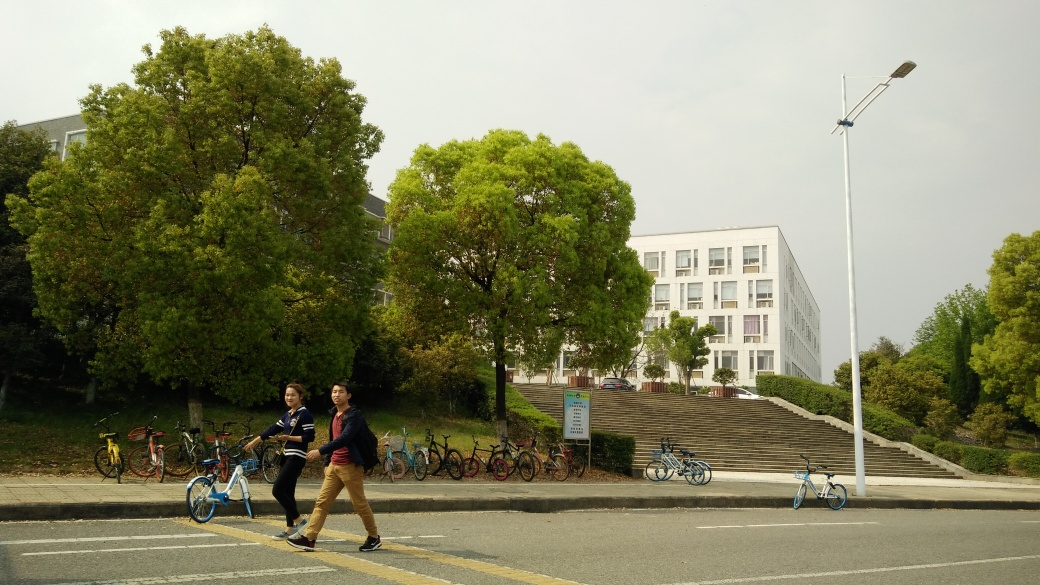Can you tell me about the architecture style of the building in the background? The building in the background exhibits a contemporary architectural style characterized by its simple, unadorned geometric forms, a flat roof, and a predominantly white façade. Such design suggests functionality and modern construction, likely indicating that the building is part of a university or institutional campus. What do the bicycles in the image tell us about this location? The presence of multiple bicycles parked to the side indicates that cycling is a popular mode of transportation in this area. This could suggest either an environmentally conscious community or a locale where distances between destinations are short enough to make cycling practical, which is common in university campuses or urban areas. 